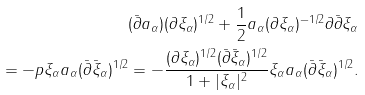Convert formula to latex. <formula><loc_0><loc_0><loc_500><loc_500>( \bar { \partial } a _ { \alpha } ) ( \partial \xi _ { \alpha } ) ^ { 1 / 2 } + \frac { 1 } { 2 } a _ { \alpha } ( \partial \xi _ { \alpha } ) ^ { - 1 / 2 } \partial \bar { \partial } \xi _ { \alpha } \\ = - p \xi _ { \alpha } a _ { \alpha } ( \bar { \partial } \bar { \xi } _ { \alpha } ) ^ { 1 / 2 } = - \frac { ( \partial \xi _ { \alpha } ) ^ { 1 / 2 } ( \bar { \partial } \bar { \xi } _ { \alpha } ) ^ { 1 / 2 } } { 1 + | \xi _ { \alpha } | ^ { 2 } } \xi _ { \alpha } a _ { \alpha } ( \bar { \partial } \bar { \xi } _ { \alpha } ) ^ { 1 / 2 } .</formula> 